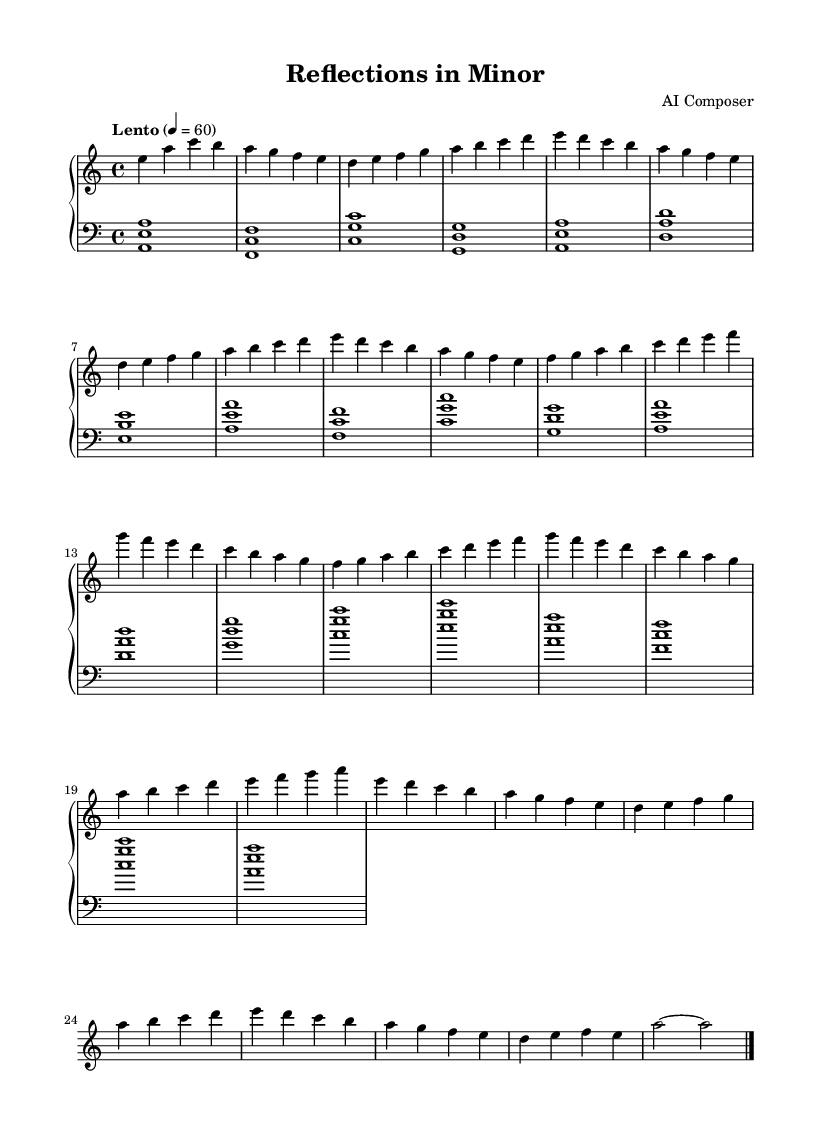What is the key signature of this composition? The key signature indicates that the piece is in the key of A minor, which has no sharps or flats.
Answer: A minor What is the time signature of this piece? The time signature shown in the music is 4/4, which signifies four beats per measure.
Answer: 4/4 What is the tempo marking indicated? The tempo marking is "Lento," which suggests a slow pace of music.
Answer: Lento How many sections are there in the composition? The composition comprises three sections labeled as A, B, and the partial A'.
Answer: Three What is the primary emotional theme expressed in this piece? The primary emotional theme expressed in the piece revolves around melancholy and self-reflection, indicated by its harmonic choices.
Answer: Melancholy During which section does the music return to A? The music returns to A during the A' section, which is a variation of the initial A section.
Answer: A' What chord is sustained in the left hand during the Coda? The Coda features a sustained A major chord in the left hand.
Answer: A major 